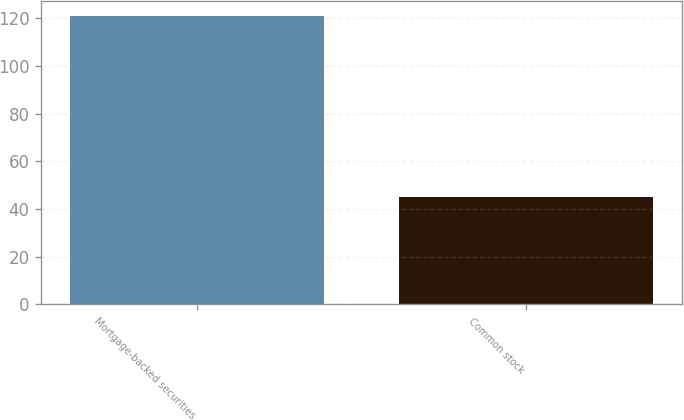Convert chart. <chart><loc_0><loc_0><loc_500><loc_500><bar_chart><fcel>Mortgage-backed securities<fcel>Common stock<nl><fcel>121<fcel>45<nl></chart> 